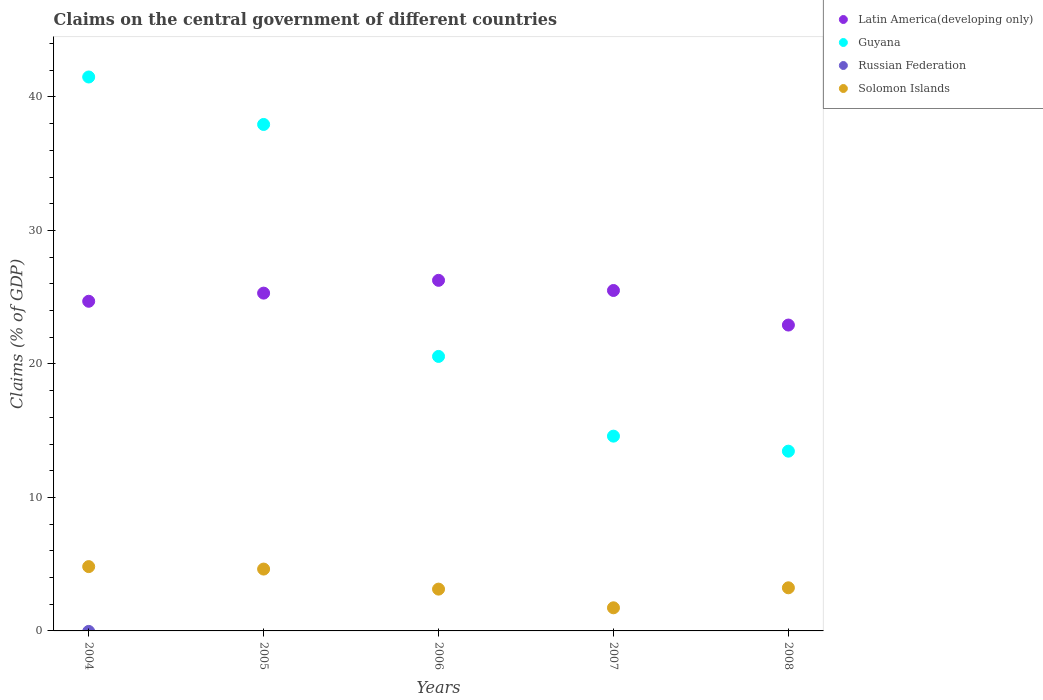How many different coloured dotlines are there?
Make the answer very short. 3. What is the percentage of GDP claimed on the central government in Guyana in 2005?
Your answer should be very brief. 37.94. Across all years, what is the maximum percentage of GDP claimed on the central government in Solomon Islands?
Provide a short and direct response. 4.82. Across all years, what is the minimum percentage of GDP claimed on the central government in Guyana?
Ensure brevity in your answer.  13.47. What is the total percentage of GDP claimed on the central government in Russian Federation in the graph?
Offer a terse response. 0. What is the difference between the percentage of GDP claimed on the central government in Guyana in 2005 and that in 2007?
Make the answer very short. 23.35. What is the difference between the percentage of GDP claimed on the central government in Solomon Islands in 2006 and the percentage of GDP claimed on the central government in Latin America(developing only) in 2005?
Offer a very short reply. -22.17. What is the average percentage of GDP claimed on the central government in Russian Federation per year?
Your answer should be compact. 0. In the year 2006, what is the difference between the percentage of GDP claimed on the central government in Solomon Islands and percentage of GDP claimed on the central government in Latin America(developing only)?
Offer a terse response. -23.13. What is the ratio of the percentage of GDP claimed on the central government in Solomon Islands in 2005 to that in 2007?
Your response must be concise. 2.67. Is the percentage of GDP claimed on the central government in Solomon Islands in 2004 less than that in 2005?
Ensure brevity in your answer.  No. What is the difference between the highest and the second highest percentage of GDP claimed on the central government in Guyana?
Keep it short and to the point. 3.56. What is the difference between the highest and the lowest percentage of GDP claimed on the central government in Solomon Islands?
Your answer should be compact. 3.09. Is it the case that in every year, the sum of the percentage of GDP claimed on the central government in Russian Federation and percentage of GDP claimed on the central government in Solomon Islands  is greater than the sum of percentage of GDP claimed on the central government in Guyana and percentage of GDP claimed on the central government in Latin America(developing only)?
Make the answer very short. No. How are the legend labels stacked?
Your answer should be compact. Vertical. What is the title of the graph?
Your answer should be compact. Claims on the central government of different countries. What is the label or title of the X-axis?
Make the answer very short. Years. What is the label or title of the Y-axis?
Ensure brevity in your answer.  Claims (% of GDP). What is the Claims (% of GDP) in Latin America(developing only) in 2004?
Give a very brief answer. 24.7. What is the Claims (% of GDP) of Guyana in 2004?
Give a very brief answer. 41.5. What is the Claims (% of GDP) of Russian Federation in 2004?
Ensure brevity in your answer.  0. What is the Claims (% of GDP) in Solomon Islands in 2004?
Keep it short and to the point. 4.82. What is the Claims (% of GDP) in Latin America(developing only) in 2005?
Ensure brevity in your answer.  25.31. What is the Claims (% of GDP) in Guyana in 2005?
Offer a terse response. 37.94. What is the Claims (% of GDP) in Solomon Islands in 2005?
Offer a terse response. 4.63. What is the Claims (% of GDP) in Latin America(developing only) in 2006?
Keep it short and to the point. 26.26. What is the Claims (% of GDP) in Guyana in 2006?
Make the answer very short. 20.56. What is the Claims (% of GDP) of Russian Federation in 2006?
Offer a very short reply. 0. What is the Claims (% of GDP) in Solomon Islands in 2006?
Make the answer very short. 3.13. What is the Claims (% of GDP) in Latin America(developing only) in 2007?
Your response must be concise. 25.5. What is the Claims (% of GDP) of Guyana in 2007?
Your response must be concise. 14.59. What is the Claims (% of GDP) of Russian Federation in 2007?
Offer a very short reply. 0. What is the Claims (% of GDP) of Solomon Islands in 2007?
Keep it short and to the point. 1.73. What is the Claims (% of GDP) in Latin America(developing only) in 2008?
Offer a very short reply. 22.91. What is the Claims (% of GDP) of Guyana in 2008?
Ensure brevity in your answer.  13.47. What is the Claims (% of GDP) in Solomon Islands in 2008?
Offer a very short reply. 3.23. Across all years, what is the maximum Claims (% of GDP) of Latin America(developing only)?
Your answer should be compact. 26.26. Across all years, what is the maximum Claims (% of GDP) of Guyana?
Provide a succinct answer. 41.5. Across all years, what is the maximum Claims (% of GDP) in Solomon Islands?
Provide a short and direct response. 4.82. Across all years, what is the minimum Claims (% of GDP) of Latin America(developing only)?
Your answer should be very brief. 22.91. Across all years, what is the minimum Claims (% of GDP) of Guyana?
Ensure brevity in your answer.  13.47. Across all years, what is the minimum Claims (% of GDP) of Solomon Islands?
Keep it short and to the point. 1.73. What is the total Claims (% of GDP) in Latin America(developing only) in the graph?
Keep it short and to the point. 124.68. What is the total Claims (% of GDP) in Guyana in the graph?
Keep it short and to the point. 128.06. What is the total Claims (% of GDP) in Russian Federation in the graph?
Ensure brevity in your answer.  0. What is the total Claims (% of GDP) of Solomon Islands in the graph?
Give a very brief answer. 17.54. What is the difference between the Claims (% of GDP) in Latin America(developing only) in 2004 and that in 2005?
Offer a very short reply. -0.61. What is the difference between the Claims (% of GDP) of Guyana in 2004 and that in 2005?
Ensure brevity in your answer.  3.56. What is the difference between the Claims (% of GDP) of Solomon Islands in 2004 and that in 2005?
Your response must be concise. 0.18. What is the difference between the Claims (% of GDP) in Latin America(developing only) in 2004 and that in 2006?
Ensure brevity in your answer.  -1.57. What is the difference between the Claims (% of GDP) of Guyana in 2004 and that in 2006?
Your response must be concise. 20.93. What is the difference between the Claims (% of GDP) in Solomon Islands in 2004 and that in 2006?
Your answer should be compact. 1.69. What is the difference between the Claims (% of GDP) in Latin America(developing only) in 2004 and that in 2007?
Your answer should be compact. -0.81. What is the difference between the Claims (% of GDP) of Guyana in 2004 and that in 2007?
Offer a very short reply. 26.91. What is the difference between the Claims (% of GDP) in Solomon Islands in 2004 and that in 2007?
Offer a very short reply. 3.09. What is the difference between the Claims (% of GDP) of Latin America(developing only) in 2004 and that in 2008?
Your answer should be very brief. 1.78. What is the difference between the Claims (% of GDP) in Guyana in 2004 and that in 2008?
Make the answer very short. 28.03. What is the difference between the Claims (% of GDP) of Solomon Islands in 2004 and that in 2008?
Offer a terse response. 1.59. What is the difference between the Claims (% of GDP) in Latin America(developing only) in 2005 and that in 2006?
Your response must be concise. -0.96. What is the difference between the Claims (% of GDP) of Guyana in 2005 and that in 2006?
Ensure brevity in your answer.  17.38. What is the difference between the Claims (% of GDP) in Solomon Islands in 2005 and that in 2006?
Make the answer very short. 1.5. What is the difference between the Claims (% of GDP) of Latin America(developing only) in 2005 and that in 2007?
Provide a short and direct response. -0.2. What is the difference between the Claims (% of GDP) of Guyana in 2005 and that in 2007?
Keep it short and to the point. 23.35. What is the difference between the Claims (% of GDP) of Solomon Islands in 2005 and that in 2007?
Keep it short and to the point. 2.9. What is the difference between the Claims (% of GDP) in Latin America(developing only) in 2005 and that in 2008?
Provide a succinct answer. 2.39. What is the difference between the Claims (% of GDP) in Guyana in 2005 and that in 2008?
Give a very brief answer. 24.48. What is the difference between the Claims (% of GDP) of Solomon Islands in 2005 and that in 2008?
Provide a short and direct response. 1.4. What is the difference between the Claims (% of GDP) of Latin America(developing only) in 2006 and that in 2007?
Offer a terse response. 0.76. What is the difference between the Claims (% of GDP) in Guyana in 2006 and that in 2007?
Ensure brevity in your answer.  5.97. What is the difference between the Claims (% of GDP) of Solomon Islands in 2006 and that in 2007?
Keep it short and to the point. 1.4. What is the difference between the Claims (% of GDP) in Latin America(developing only) in 2006 and that in 2008?
Offer a terse response. 3.35. What is the difference between the Claims (% of GDP) in Guyana in 2006 and that in 2008?
Your response must be concise. 7.1. What is the difference between the Claims (% of GDP) of Solomon Islands in 2006 and that in 2008?
Give a very brief answer. -0.1. What is the difference between the Claims (% of GDP) in Latin America(developing only) in 2007 and that in 2008?
Provide a succinct answer. 2.59. What is the difference between the Claims (% of GDP) of Guyana in 2007 and that in 2008?
Offer a terse response. 1.13. What is the difference between the Claims (% of GDP) of Solomon Islands in 2007 and that in 2008?
Offer a terse response. -1.5. What is the difference between the Claims (% of GDP) in Latin America(developing only) in 2004 and the Claims (% of GDP) in Guyana in 2005?
Provide a succinct answer. -13.25. What is the difference between the Claims (% of GDP) of Latin America(developing only) in 2004 and the Claims (% of GDP) of Solomon Islands in 2005?
Your response must be concise. 20.06. What is the difference between the Claims (% of GDP) in Guyana in 2004 and the Claims (% of GDP) in Solomon Islands in 2005?
Provide a succinct answer. 36.86. What is the difference between the Claims (% of GDP) in Latin America(developing only) in 2004 and the Claims (% of GDP) in Guyana in 2006?
Ensure brevity in your answer.  4.13. What is the difference between the Claims (% of GDP) in Latin America(developing only) in 2004 and the Claims (% of GDP) in Solomon Islands in 2006?
Provide a succinct answer. 21.56. What is the difference between the Claims (% of GDP) in Guyana in 2004 and the Claims (% of GDP) in Solomon Islands in 2006?
Ensure brevity in your answer.  38.37. What is the difference between the Claims (% of GDP) of Latin America(developing only) in 2004 and the Claims (% of GDP) of Guyana in 2007?
Provide a short and direct response. 10.1. What is the difference between the Claims (% of GDP) of Latin America(developing only) in 2004 and the Claims (% of GDP) of Solomon Islands in 2007?
Your answer should be compact. 22.96. What is the difference between the Claims (% of GDP) in Guyana in 2004 and the Claims (% of GDP) in Solomon Islands in 2007?
Offer a terse response. 39.77. What is the difference between the Claims (% of GDP) in Latin America(developing only) in 2004 and the Claims (% of GDP) in Guyana in 2008?
Your response must be concise. 11.23. What is the difference between the Claims (% of GDP) in Latin America(developing only) in 2004 and the Claims (% of GDP) in Solomon Islands in 2008?
Offer a terse response. 21.47. What is the difference between the Claims (% of GDP) of Guyana in 2004 and the Claims (% of GDP) of Solomon Islands in 2008?
Make the answer very short. 38.27. What is the difference between the Claims (% of GDP) in Latin America(developing only) in 2005 and the Claims (% of GDP) in Guyana in 2006?
Provide a short and direct response. 4.74. What is the difference between the Claims (% of GDP) in Latin America(developing only) in 2005 and the Claims (% of GDP) in Solomon Islands in 2006?
Your answer should be very brief. 22.17. What is the difference between the Claims (% of GDP) of Guyana in 2005 and the Claims (% of GDP) of Solomon Islands in 2006?
Offer a very short reply. 34.81. What is the difference between the Claims (% of GDP) in Latin America(developing only) in 2005 and the Claims (% of GDP) in Guyana in 2007?
Give a very brief answer. 10.71. What is the difference between the Claims (% of GDP) of Latin America(developing only) in 2005 and the Claims (% of GDP) of Solomon Islands in 2007?
Provide a succinct answer. 23.57. What is the difference between the Claims (% of GDP) of Guyana in 2005 and the Claims (% of GDP) of Solomon Islands in 2007?
Make the answer very short. 36.21. What is the difference between the Claims (% of GDP) of Latin America(developing only) in 2005 and the Claims (% of GDP) of Guyana in 2008?
Your response must be concise. 11.84. What is the difference between the Claims (% of GDP) in Latin America(developing only) in 2005 and the Claims (% of GDP) in Solomon Islands in 2008?
Keep it short and to the point. 22.08. What is the difference between the Claims (% of GDP) of Guyana in 2005 and the Claims (% of GDP) of Solomon Islands in 2008?
Provide a succinct answer. 34.71. What is the difference between the Claims (% of GDP) in Latin America(developing only) in 2006 and the Claims (% of GDP) in Guyana in 2007?
Your response must be concise. 11.67. What is the difference between the Claims (% of GDP) in Latin America(developing only) in 2006 and the Claims (% of GDP) in Solomon Islands in 2007?
Ensure brevity in your answer.  24.53. What is the difference between the Claims (% of GDP) of Guyana in 2006 and the Claims (% of GDP) of Solomon Islands in 2007?
Give a very brief answer. 18.83. What is the difference between the Claims (% of GDP) in Latin America(developing only) in 2006 and the Claims (% of GDP) in Guyana in 2008?
Your answer should be compact. 12.8. What is the difference between the Claims (% of GDP) of Latin America(developing only) in 2006 and the Claims (% of GDP) of Solomon Islands in 2008?
Keep it short and to the point. 23.03. What is the difference between the Claims (% of GDP) of Guyana in 2006 and the Claims (% of GDP) of Solomon Islands in 2008?
Give a very brief answer. 17.33. What is the difference between the Claims (% of GDP) in Latin America(developing only) in 2007 and the Claims (% of GDP) in Guyana in 2008?
Make the answer very short. 12.04. What is the difference between the Claims (% of GDP) in Latin America(developing only) in 2007 and the Claims (% of GDP) in Solomon Islands in 2008?
Make the answer very short. 22.27. What is the difference between the Claims (% of GDP) of Guyana in 2007 and the Claims (% of GDP) of Solomon Islands in 2008?
Your response must be concise. 11.36. What is the average Claims (% of GDP) of Latin America(developing only) per year?
Your response must be concise. 24.94. What is the average Claims (% of GDP) in Guyana per year?
Keep it short and to the point. 25.61. What is the average Claims (% of GDP) in Solomon Islands per year?
Your answer should be very brief. 3.51. In the year 2004, what is the difference between the Claims (% of GDP) of Latin America(developing only) and Claims (% of GDP) of Guyana?
Give a very brief answer. -16.8. In the year 2004, what is the difference between the Claims (% of GDP) of Latin America(developing only) and Claims (% of GDP) of Solomon Islands?
Your answer should be compact. 19.88. In the year 2004, what is the difference between the Claims (% of GDP) in Guyana and Claims (% of GDP) in Solomon Islands?
Your response must be concise. 36.68. In the year 2005, what is the difference between the Claims (% of GDP) in Latin America(developing only) and Claims (% of GDP) in Guyana?
Offer a very short reply. -12.64. In the year 2005, what is the difference between the Claims (% of GDP) in Latin America(developing only) and Claims (% of GDP) in Solomon Islands?
Your response must be concise. 20.67. In the year 2005, what is the difference between the Claims (% of GDP) in Guyana and Claims (% of GDP) in Solomon Islands?
Offer a very short reply. 33.31. In the year 2006, what is the difference between the Claims (% of GDP) in Latin America(developing only) and Claims (% of GDP) in Guyana?
Give a very brief answer. 5.7. In the year 2006, what is the difference between the Claims (% of GDP) in Latin America(developing only) and Claims (% of GDP) in Solomon Islands?
Your answer should be compact. 23.13. In the year 2006, what is the difference between the Claims (% of GDP) in Guyana and Claims (% of GDP) in Solomon Islands?
Your answer should be very brief. 17.43. In the year 2007, what is the difference between the Claims (% of GDP) in Latin America(developing only) and Claims (% of GDP) in Guyana?
Ensure brevity in your answer.  10.91. In the year 2007, what is the difference between the Claims (% of GDP) in Latin America(developing only) and Claims (% of GDP) in Solomon Islands?
Provide a succinct answer. 23.77. In the year 2007, what is the difference between the Claims (% of GDP) in Guyana and Claims (% of GDP) in Solomon Islands?
Your answer should be very brief. 12.86. In the year 2008, what is the difference between the Claims (% of GDP) in Latin America(developing only) and Claims (% of GDP) in Guyana?
Offer a very short reply. 9.45. In the year 2008, what is the difference between the Claims (% of GDP) of Latin America(developing only) and Claims (% of GDP) of Solomon Islands?
Make the answer very short. 19.68. In the year 2008, what is the difference between the Claims (% of GDP) of Guyana and Claims (% of GDP) of Solomon Islands?
Your response must be concise. 10.24. What is the ratio of the Claims (% of GDP) in Latin America(developing only) in 2004 to that in 2005?
Offer a very short reply. 0.98. What is the ratio of the Claims (% of GDP) of Guyana in 2004 to that in 2005?
Ensure brevity in your answer.  1.09. What is the ratio of the Claims (% of GDP) in Solomon Islands in 2004 to that in 2005?
Your answer should be very brief. 1.04. What is the ratio of the Claims (% of GDP) of Latin America(developing only) in 2004 to that in 2006?
Ensure brevity in your answer.  0.94. What is the ratio of the Claims (% of GDP) in Guyana in 2004 to that in 2006?
Make the answer very short. 2.02. What is the ratio of the Claims (% of GDP) in Solomon Islands in 2004 to that in 2006?
Provide a short and direct response. 1.54. What is the ratio of the Claims (% of GDP) in Latin America(developing only) in 2004 to that in 2007?
Your answer should be very brief. 0.97. What is the ratio of the Claims (% of GDP) in Guyana in 2004 to that in 2007?
Provide a succinct answer. 2.84. What is the ratio of the Claims (% of GDP) of Solomon Islands in 2004 to that in 2007?
Offer a terse response. 2.78. What is the ratio of the Claims (% of GDP) of Latin America(developing only) in 2004 to that in 2008?
Your answer should be compact. 1.08. What is the ratio of the Claims (% of GDP) in Guyana in 2004 to that in 2008?
Your response must be concise. 3.08. What is the ratio of the Claims (% of GDP) in Solomon Islands in 2004 to that in 2008?
Your answer should be very brief. 1.49. What is the ratio of the Claims (% of GDP) in Latin America(developing only) in 2005 to that in 2006?
Your answer should be very brief. 0.96. What is the ratio of the Claims (% of GDP) of Guyana in 2005 to that in 2006?
Give a very brief answer. 1.84. What is the ratio of the Claims (% of GDP) of Solomon Islands in 2005 to that in 2006?
Your answer should be compact. 1.48. What is the ratio of the Claims (% of GDP) in Guyana in 2005 to that in 2007?
Offer a terse response. 2.6. What is the ratio of the Claims (% of GDP) of Solomon Islands in 2005 to that in 2007?
Make the answer very short. 2.67. What is the ratio of the Claims (% of GDP) of Latin America(developing only) in 2005 to that in 2008?
Your answer should be very brief. 1.1. What is the ratio of the Claims (% of GDP) in Guyana in 2005 to that in 2008?
Offer a very short reply. 2.82. What is the ratio of the Claims (% of GDP) of Solomon Islands in 2005 to that in 2008?
Keep it short and to the point. 1.43. What is the ratio of the Claims (% of GDP) in Latin America(developing only) in 2006 to that in 2007?
Your answer should be compact. 1.03. What is the ratio of the Claims (% of GDP) of Guyana in 2006 to that in 2007?
Your answer should be compact. 1.41. What is the ratio of the Claims (% of GDP) in Solomon Islands in 2006 to that in 2007?
Keep it short and to the point. 1.81. What is the ratio of the Claims (% of GDP) of Latin America(developing only) in 2006 to that in 2008?
Your answer should be very brief. 1.15. What is the ratio of the Claims (% of GDP) in Guyana in 2006 to that in 2008?
Offer a terse response. 1.53. What is the ratio of the Claims (% of GDP) in Solomon Islands in 2006 to that in 2008?
Provide a succinct answer. 0.97. What is the ratio of the Claims (% of GDP) in Latin America(developing only) in 2007 to that in 2008?
Your answer should be compact. 1.11. What is the ratio of the Claims (% of GDP) in Guyana in 2007 to that in 2008?
Provide a succinct answer. 1.08. What is the ratio of the Claims (% of GDP) in Solomon Islands in 2007 to that in 2008?
Your answer should be compact. 0.54. What is the difference between the highest and the second highest Claims (% of GDP) in Latin America(developing only)?
Ensure brevity in your answer.  0.76. What is the difference between the highest and the second highest Claims (% of GDP) of Guyana?
Make the answer very short. 3.56. What is the difference between the highest and the second highest Claims (% of GDP) in Solomon Islands?
Give a very brief answer. 0.18. What is the difference between the highest and the lowest Claims (% of GDP) in Latin America(developing only)?
Your answer should be compact. 3.35. What is the difference between the highest and the lowest Claims (% of GDP) of Guyana?
Offer a terse response. 28.03. What is the difference between the highest and the lowest Claims (% of GDP) in Solomon Islands?
Offer a terse response. 3.09. 